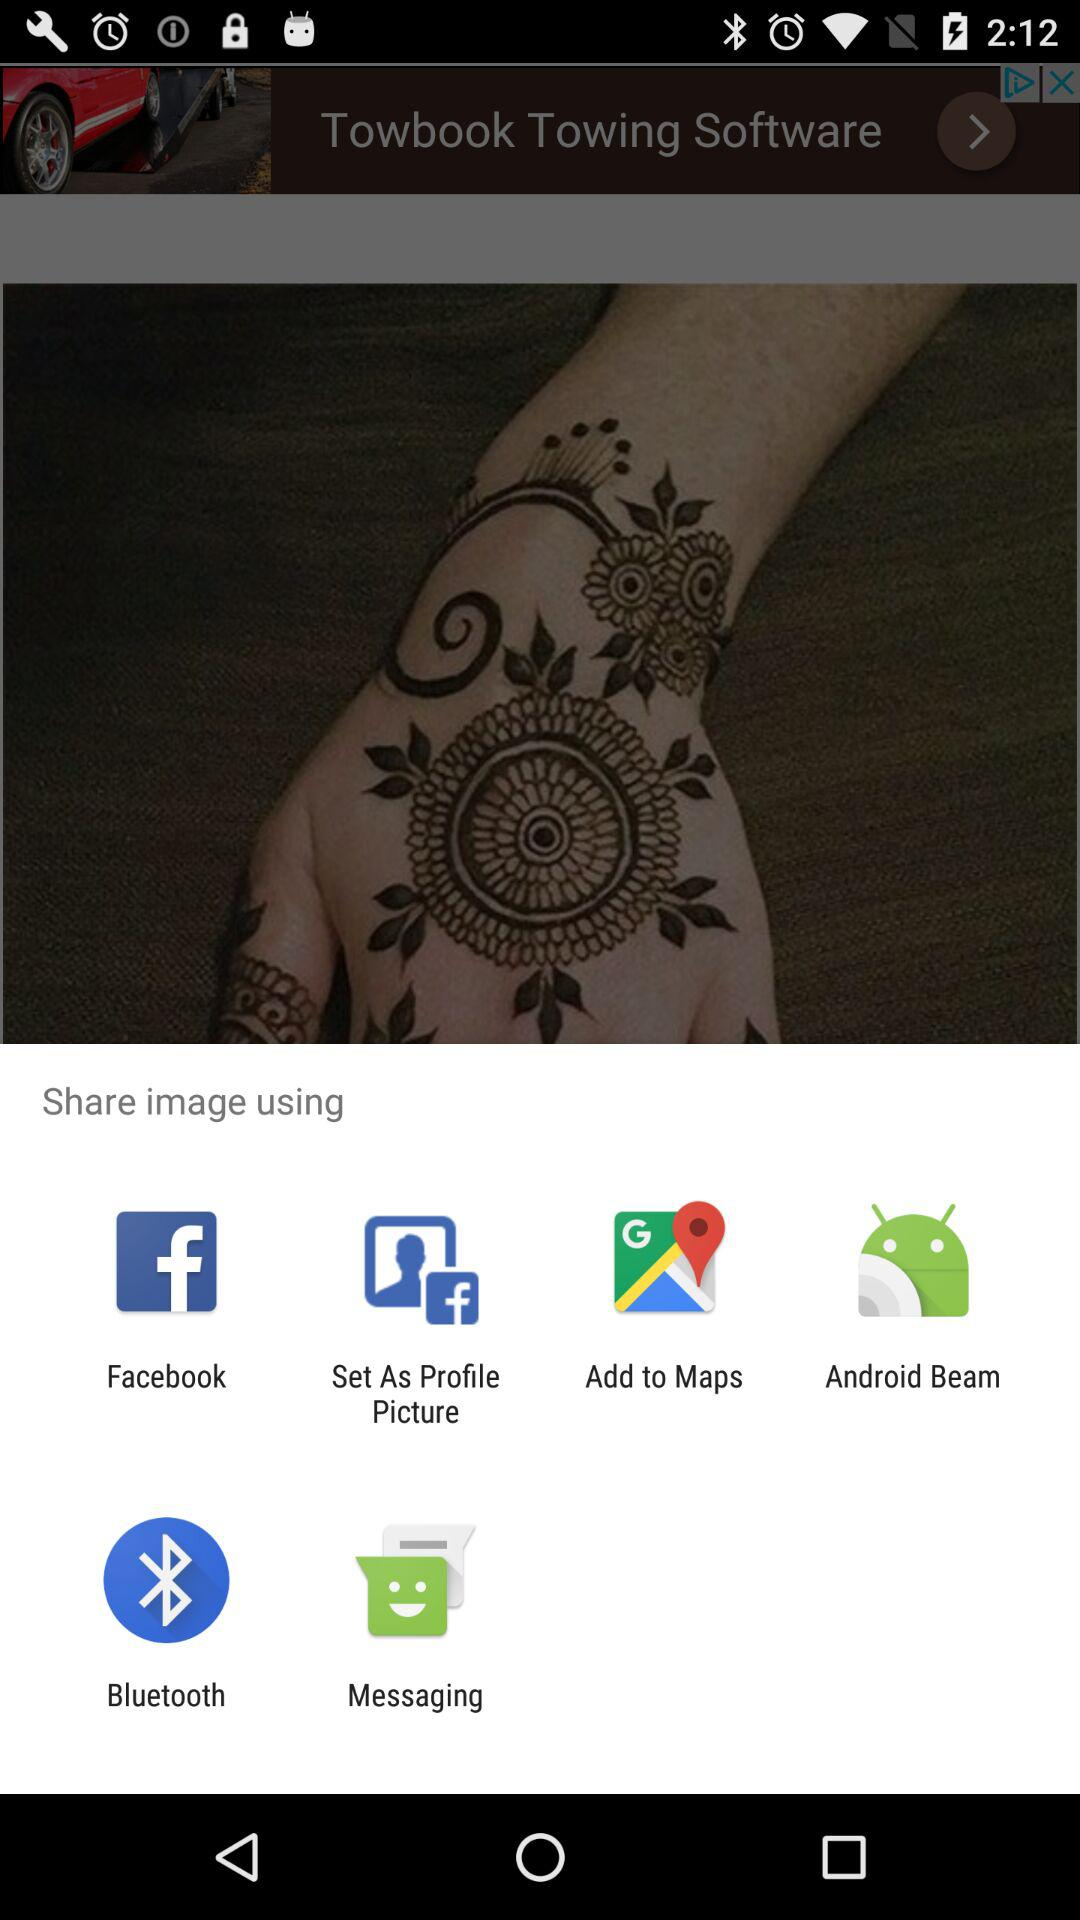Which are the different sharing options? The different sharing options are "Facebook", "Set As Profile Picture", "Add to Maps", "Android Beam", "Bluetooth" and "Messaging". 